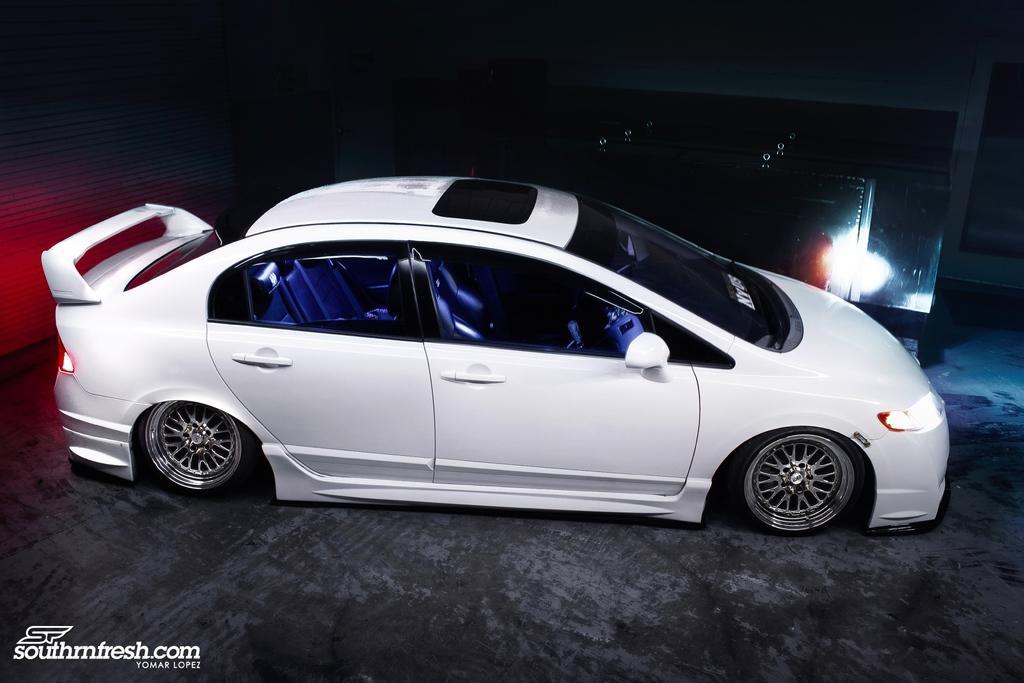Please provide a concise description of this image. In this image there is a vehicle, behind the vehicle there is an object. The background is dark. At the bottom left side of the image there is some text. 